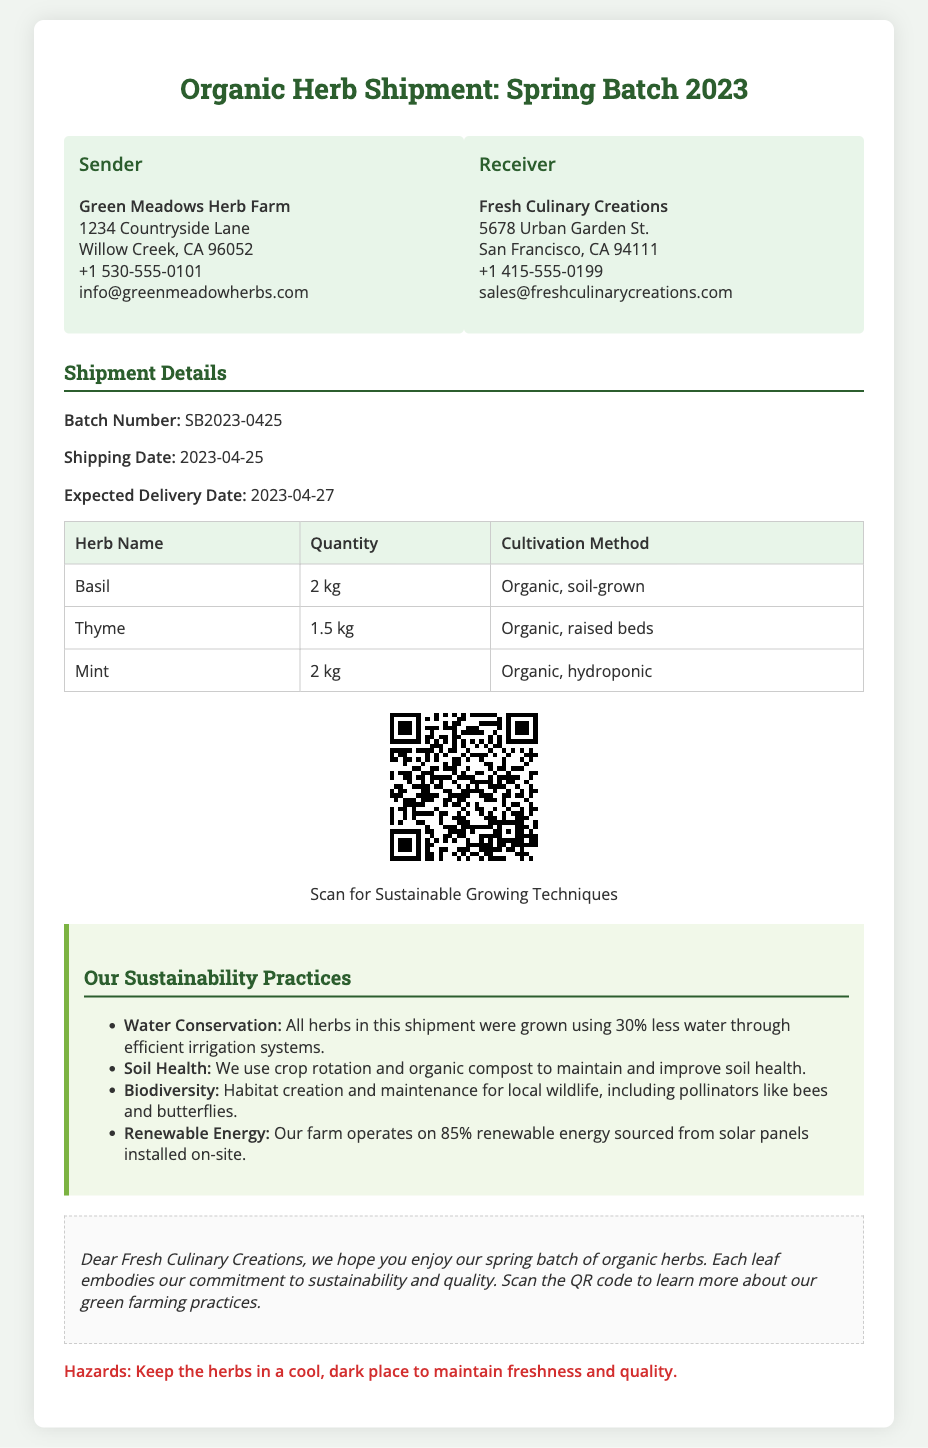What is the sender's name? The sender's name is clearly mentioned at the top of the shipping label under the sender's section.
Answer: Green Meadows Herb Farm What is the receiver's email address? The receiver's email is provided in the receiver's section for contact purposes.
Answer: sales@freshculinarycreations.com What is the shipping date? The shipping date is listed in the shipment details section of the document.
Answer: 2023-04-25 What is the quantity of Mint in the shipment? The quantity of Mint is specified in the table summarizing the herbs in the shipment.
Answer: 2 kg What is the batch number of this shipment? The batch number is presented as a unique identifier in the shipment details section.
Answer: SB2023-0425 How much renewable energy does the farm operate on? The percentage of renewable energy used by the farm is outlined in the sustainability practices section.
Answer: 85% What cultivation method is used for Thyme? The cultivation method is indicated in the herb details section of the table.
Answer: Organic, raised beds What hazard is associated with the herbs? The document includes a specific hazard warning related to the storage conditions of the herbs.
Answer: Keep the herbs in a cool, dark place How many types of herbs are listed in the document? The number of herb types can be counted by referencing the entries in the herbs table.
Answer: 3 What can be scanned for more information about sustainable practices? The document mentions a QR code that links to further information about sustainable growing techniques.
Answer: QR Code for Sustainable Growing Techniques 